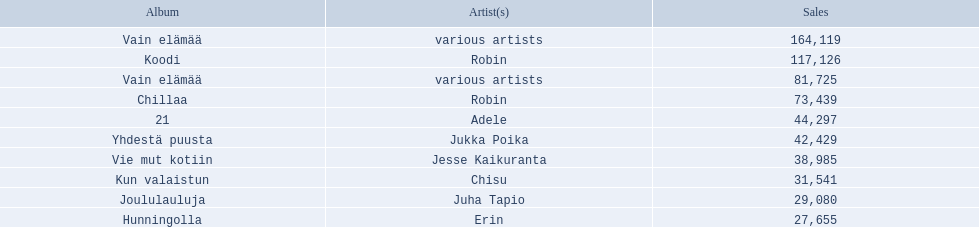Which artists' albums reached number one in finland during 2012? 164,119, 117,126, 81,725, 73,439, 44,297, 42,429, 38,985, 31,541, 29,080, 27,655. What were the sales figures of these albums? Various artists, robin, various artists, robin, adele, jukka poika, jesse kaikuranta, chisu, juha tapio, erin. And did adele or chisu have more sales during this period? Adele. 